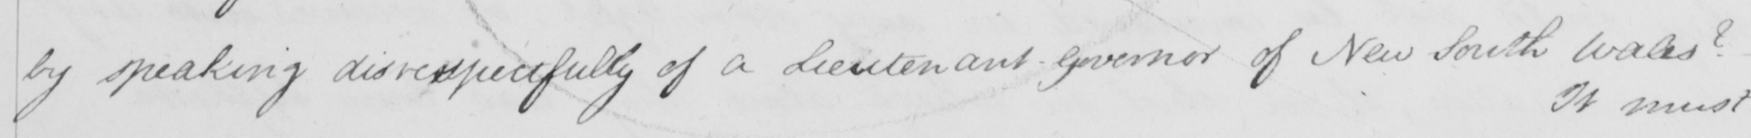What does this handwritten line say? by speaking disrespectfully of a Lieutenant-Governor of New South Wales ?   _ 